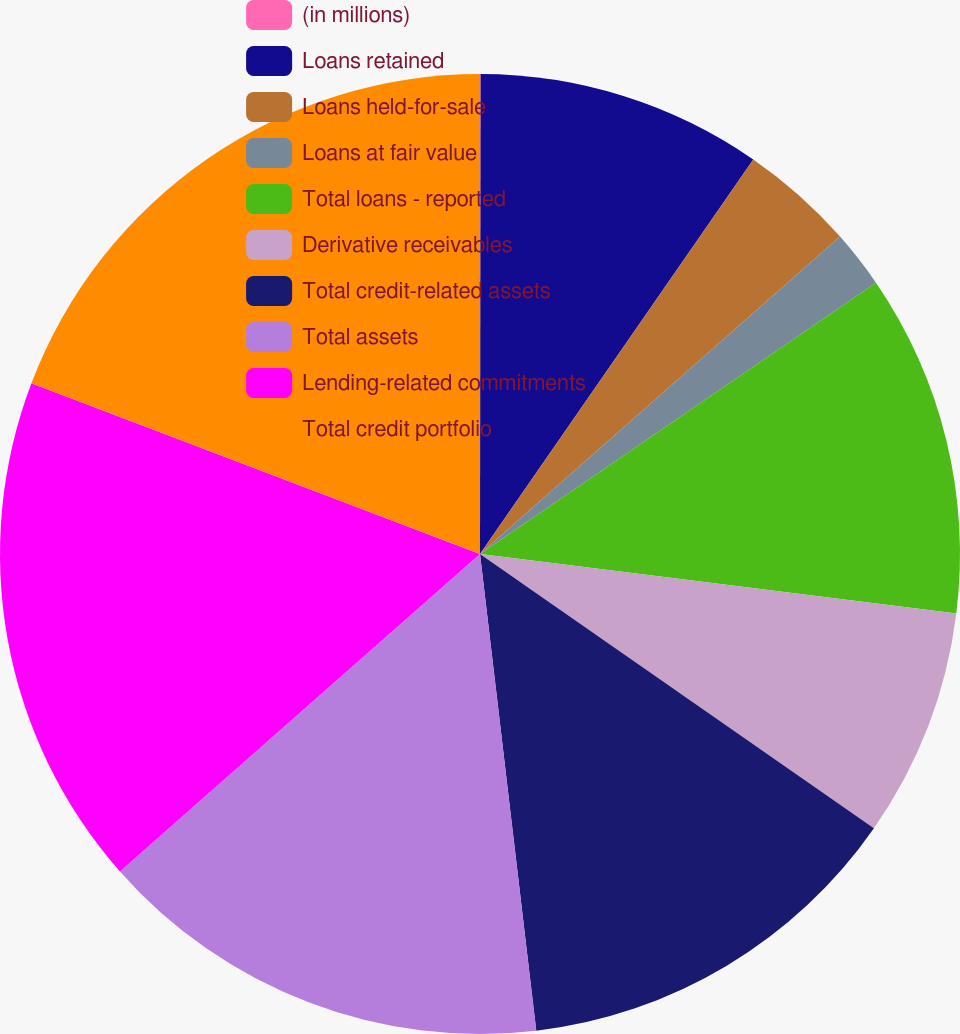<chart> <loc_0><loc_0><loc_500><loc_500><pie_chart><fcel>(in millions)<fcel>Loans retained<fcel>Loans held-for-sale<fcel>Loans at fair value<fcel>Total loans - reported<fcel>Derivative receivables<fcel>Total credit-related assets<fcel>Total assets<fcel>Lending-related commitments<fcel>Total credit portfolio<nl><fcel>0.02%<fcel>9.62%<fcel>3.86%<fcel>1.94%<fcel>11.54%<fcel>7.7%<fcel>13.45%<fcel>15.37%<fcel>17.29%<fcel>19.21%<nl></chart> 